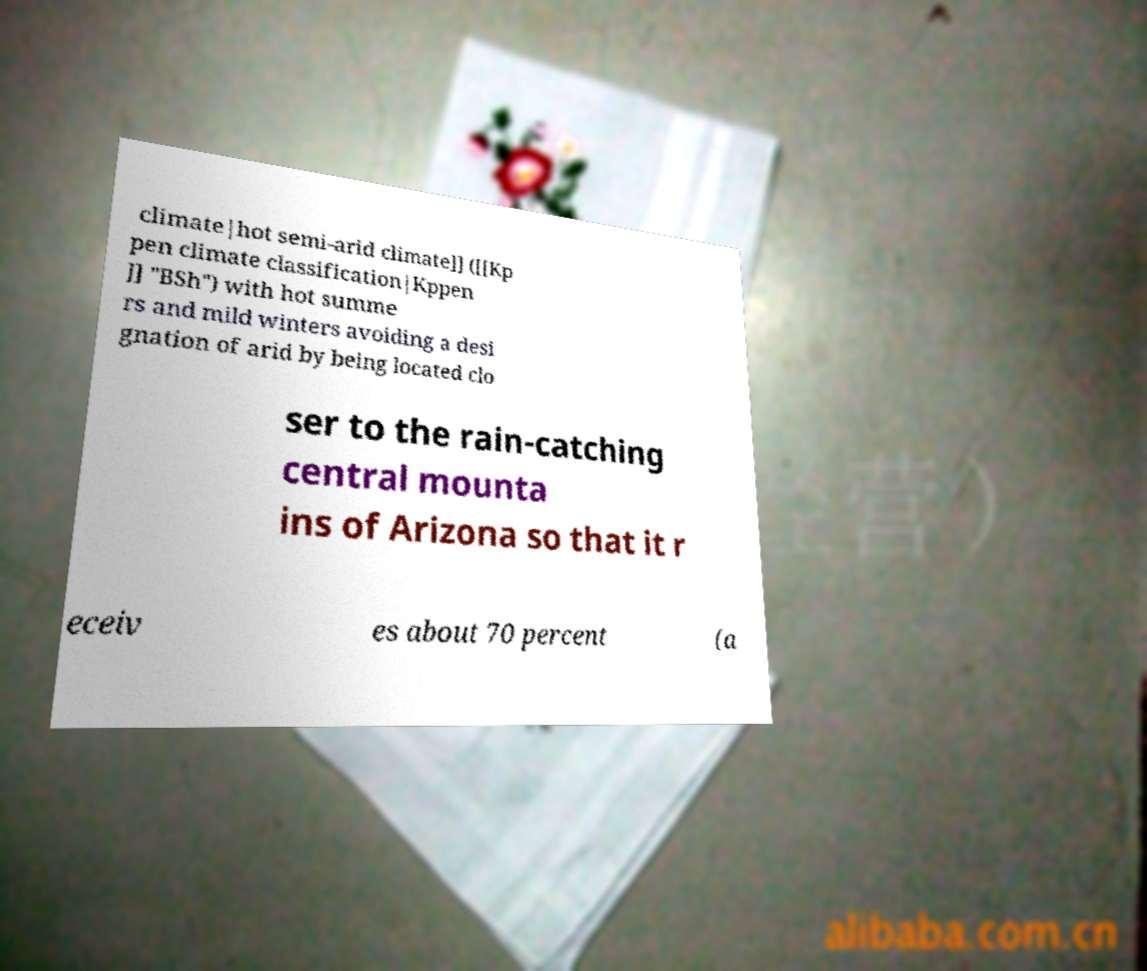Can you accurately transcribe the text from the provided image for me? climate|hot semi-arid climate]] ([[Kp pen climate classification|Kppen ]] "BSh") with hot summe rs and mild winters avoiding a desi gnation of arid by being located clo ser to the rain-catching central mounta ins of Arizona so that it r eceiv es about 70 percent (a 